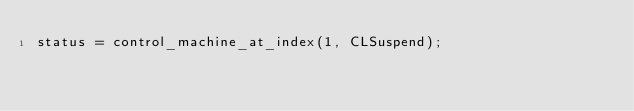Convert code to text. <code><loc_0><loc_0><loc_500><loc_500><_ObjectiveC_>status = control_machine_at_index(1, CLSuspend);
</code> 